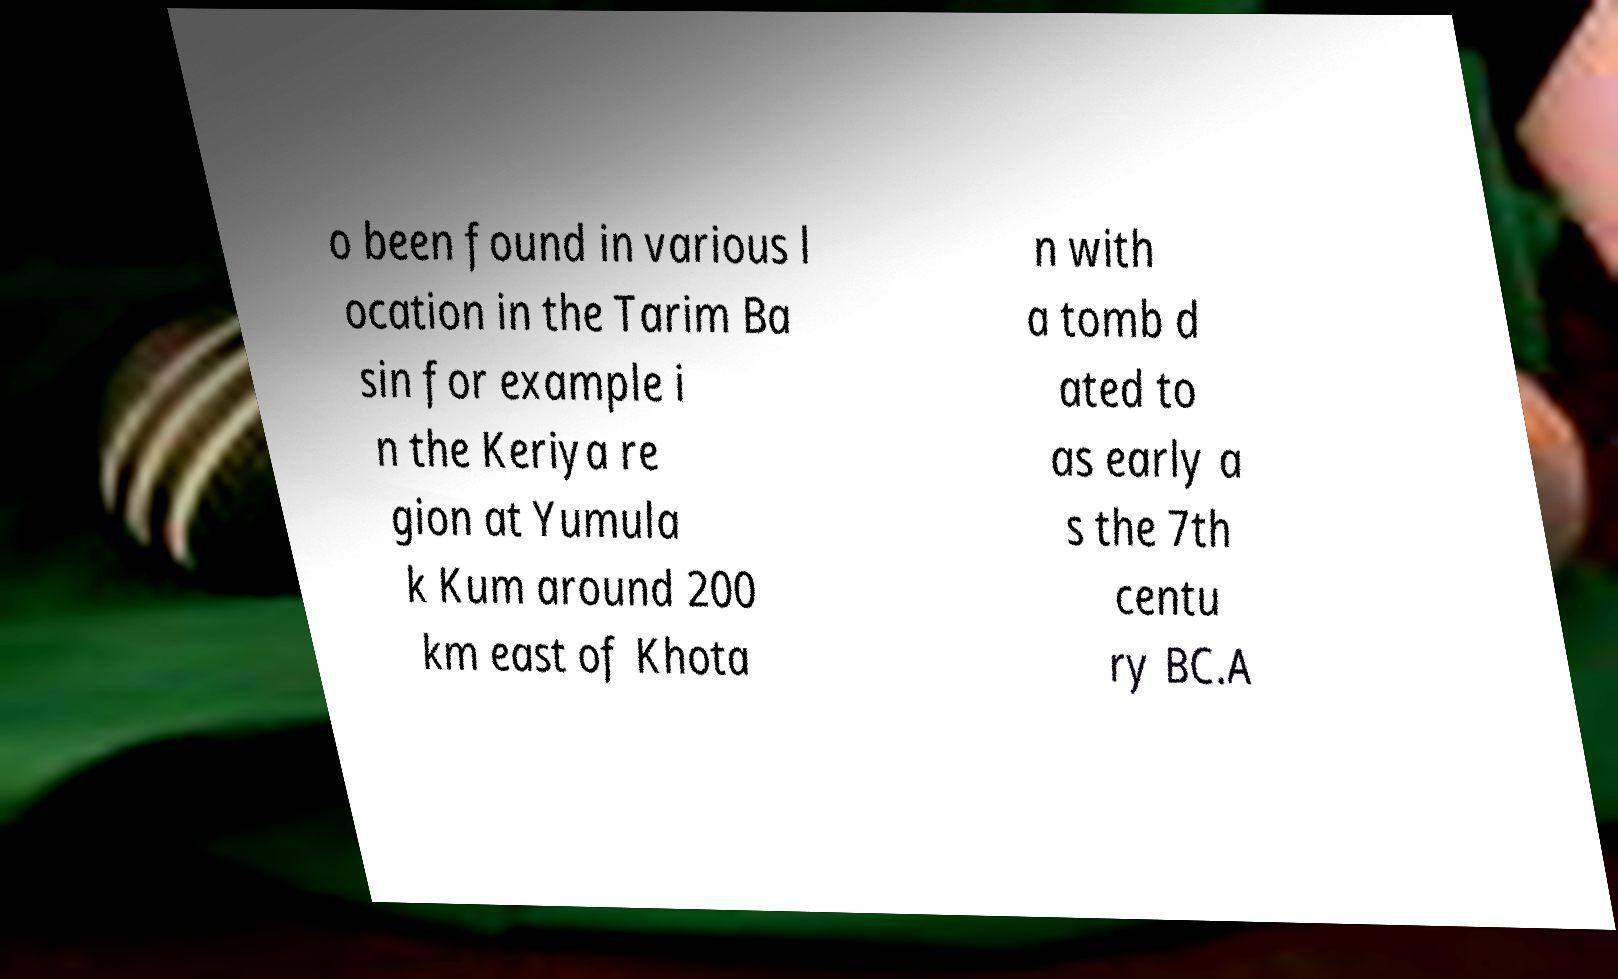I need the written content from this picture converted into text. Can you do that? o been found in various l ocation in the Tarim Ba sin for example i n the Keriya re gion at Yumula k Kum around 200 km east of Khota n with a tomb d ated to as early a s the 7th centu ry BC.A 